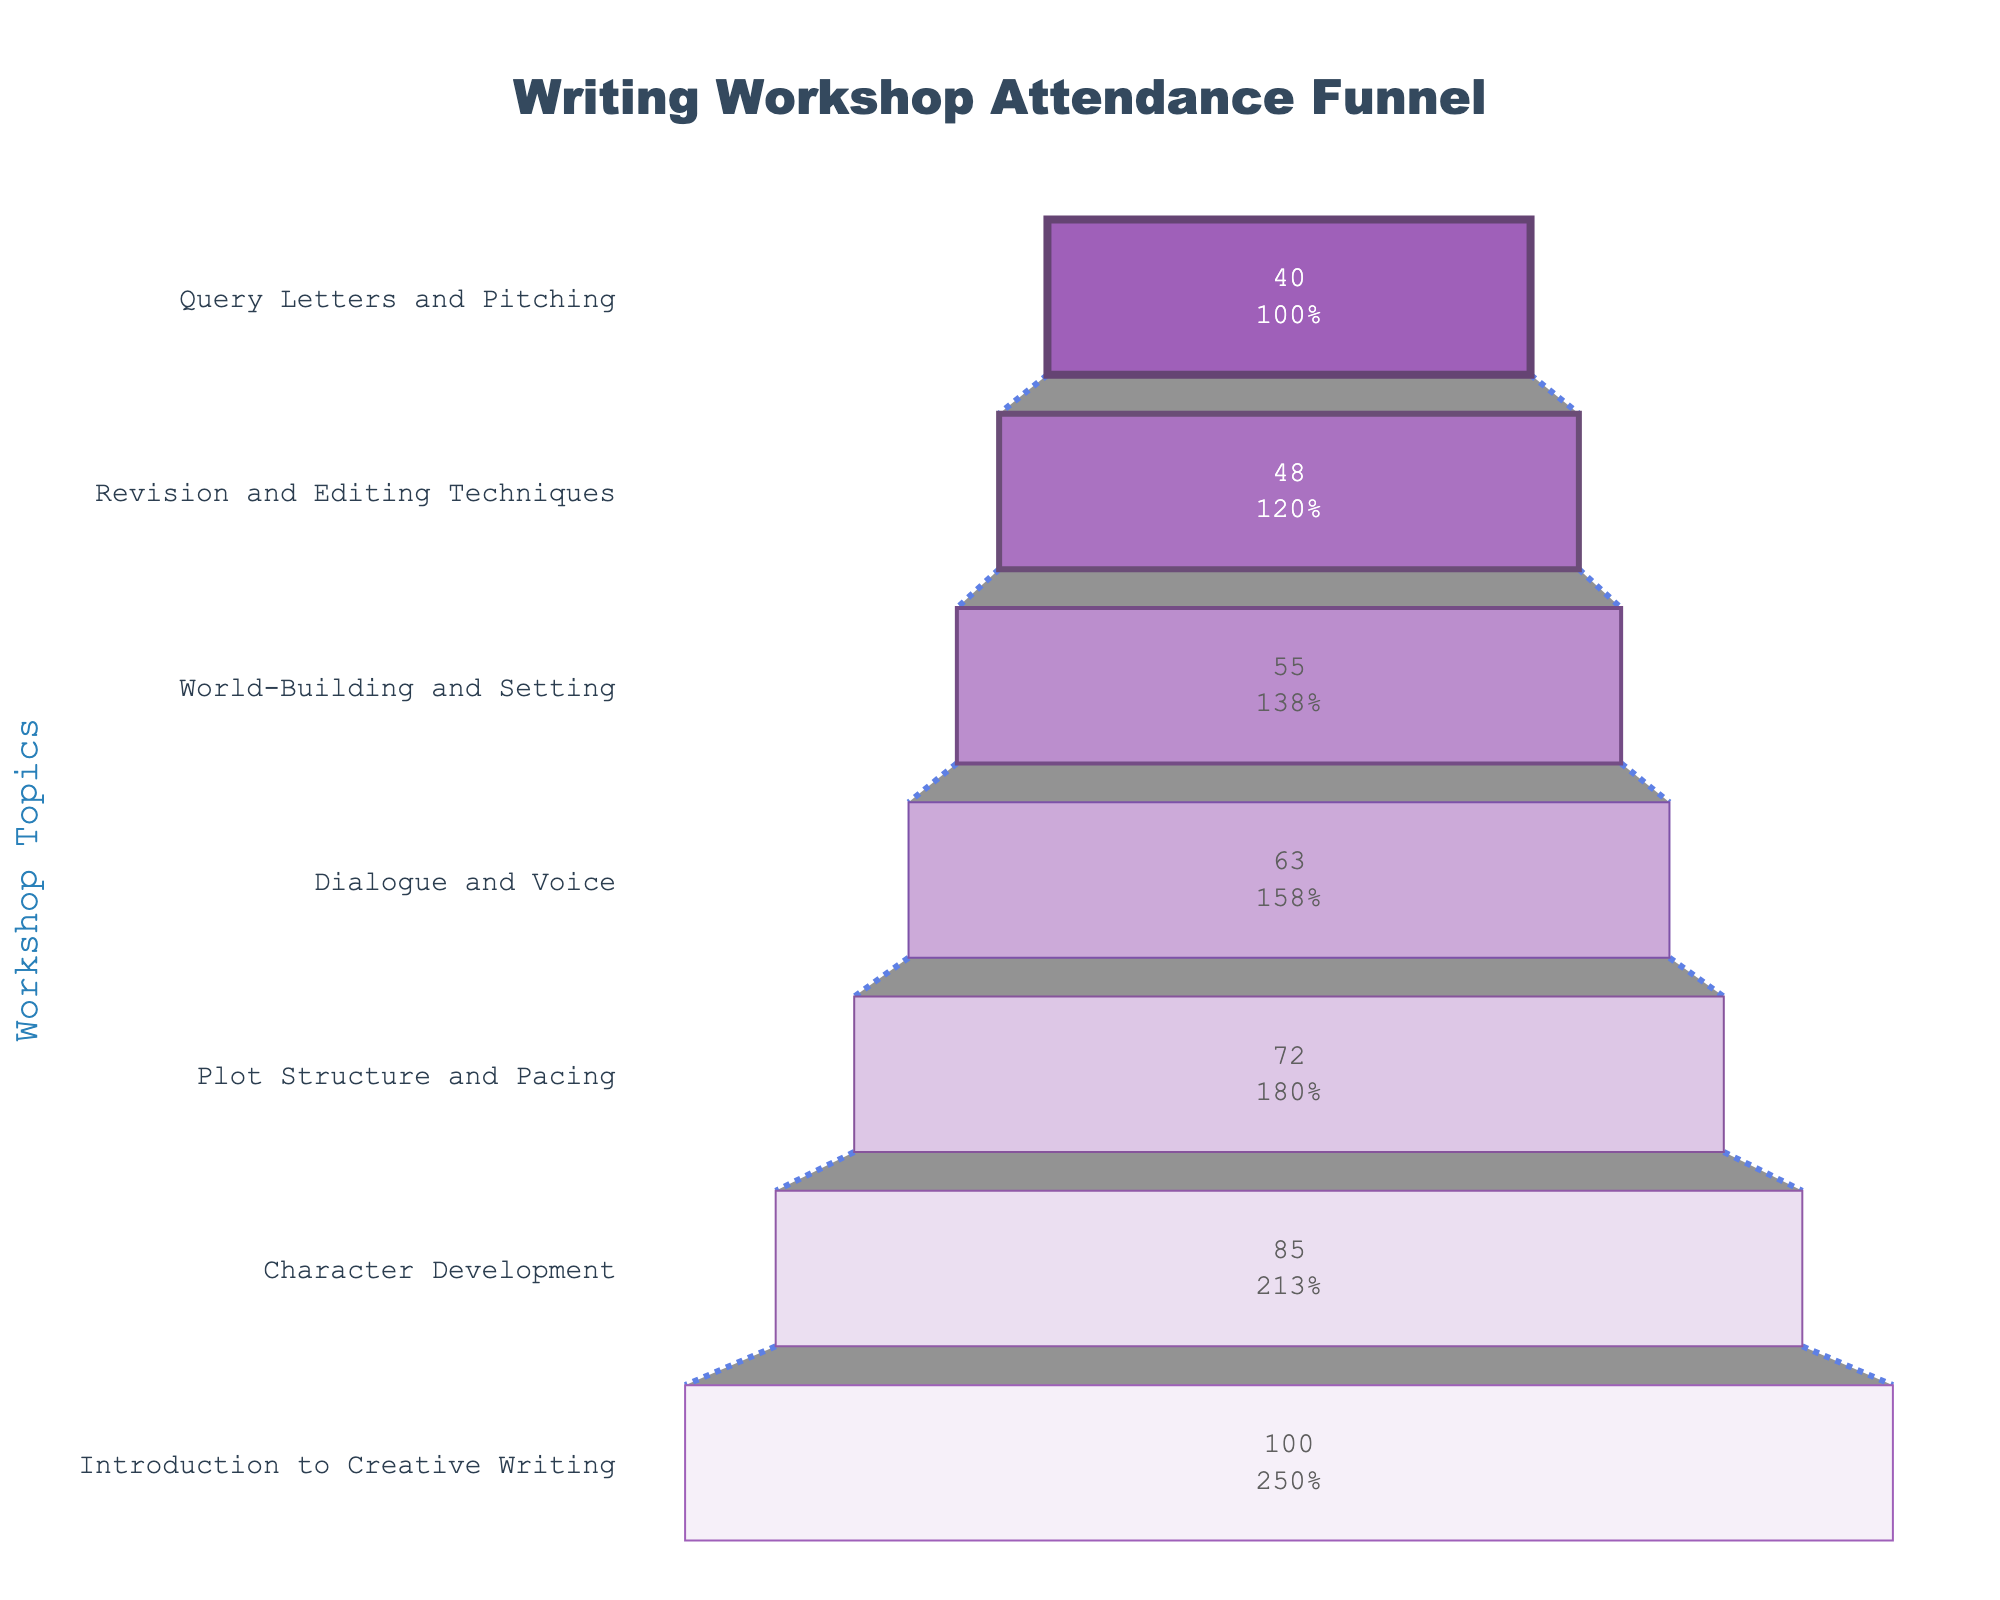What is the title of the figure? The title is located at the top of the figure. It provides a concise summary of what the figure represents.
Answer: Writing Workshop Attendance Funnel How many workshops are included in the chart? Count the number of distinct workshops listed on the y-axis of the funnel chart.
Answer: 7 Which workshop has the highest attendance? The workshop at the top of the funnel chart represents the one with the highest attendance.
Answer: Introduction to Creative Writing How many attendees are at the "Dialogue and Voice" workshop? Refer to the data label on the "Dialogue and Voice" section of the funnel.
Answer: 63 What percentage of the initial attendees remained by the "World-Building and Setting" workshop? The percentage is shown as part of the text inside the funnel chart for the "World-Building and Setting" segment.
Answer: 55% How many attendees dropped between the "Character Development" and "Plot Structure and Pacing" workshops? Subtract the number of attendees in "Plot Structure and Pacing" from those in "Character Development" (85 - 72).
Answer: 13 What is the combined total of attendees for the last three workshops? Sum the number of attendees in the last three workshops: "Revision and Editing Techniques" (48), "Query Letters and Pitching" (40), and "World-Building and Setting" (55) (48 + 40 + 55).
Answer: 143 Which workshop experienced the largest drop in attendance compared to the previous workshop? Calculate the difference in attendees between each pair of consecutive workshops and identify the largest drop: (100-85), (85-72), (72-63), (63-55), (55-48), (48-40). The largest difference is 15 (100 - 85).
Answer: Introduction to Creative Writing -> Character Development What is the average number of attendees for all workshops? Sum the number of attendees across all workshops and divide by the total number of workshops (100 + 85 + 72 + 63 + 55 + 48 + 40) / 7.
Answer: 66.14 How many unique colors are used in the funnel chart? Observe the distinct colors used for different segments in the funnel chart.
Answer: 7 